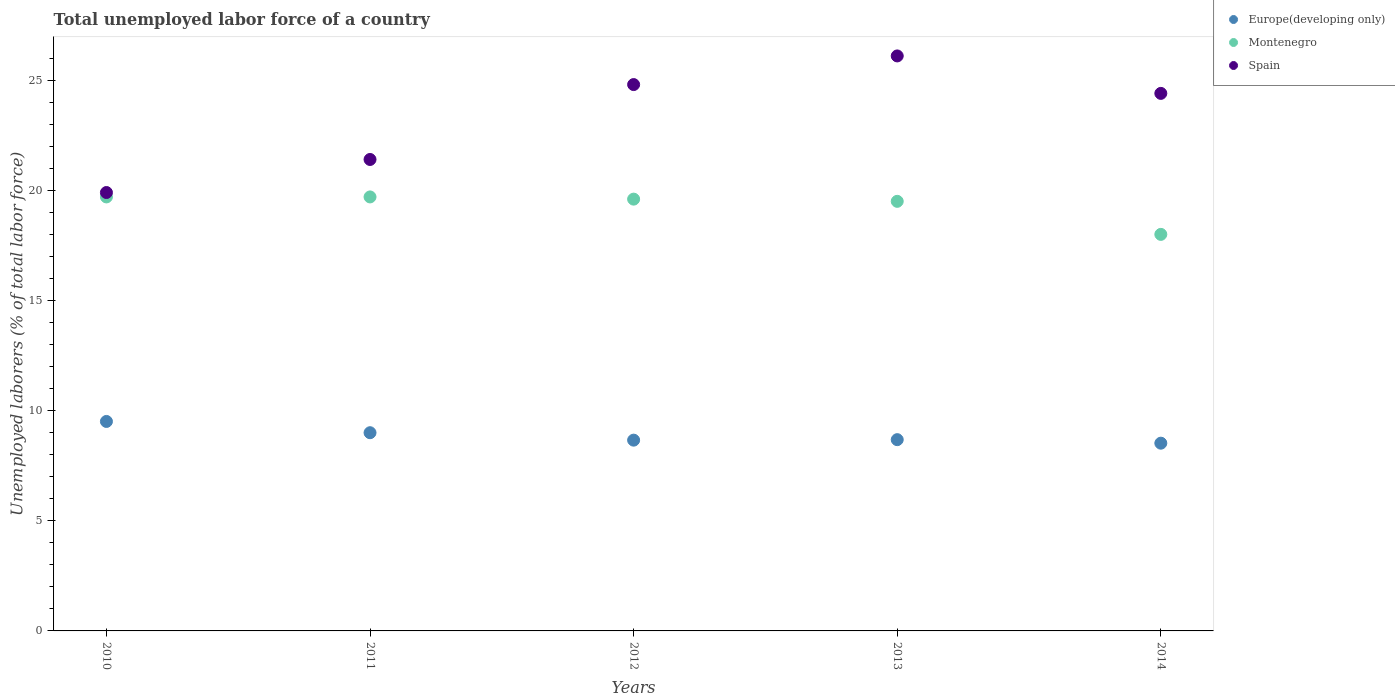What is the total unemployed labor force in Spain in 2010?
Provide a succinct answer. 19.9. Across all years, what is the maximum total unemployed labor force in Montenegro?
Your answer should be compact. 19.7. What is the total total unemployed labor force in Europe(developing only) in the graph?
Your answer should be compact. 44.37. What is the difference between the total unemployed labor force in Europe(developing only) in 2011 and that in 2013?
Offer a terse response. 0.32. What is the difference between the total unemployed labor force in Montenegro in 2013 and the total unemployed labor force in Spain in 2010?
Provide a succinct answer. -0.4. What is the average total unemployed labor force in Europe(developing only) per year?
Provide a short and direct response. 8.87. In the year 2013, what is the difference between the total unemployed labor force in Spain and total unemployed labor force in Montenegro?
Provide a short and direct response. 6.6. What is the ratio of the total unemployed labor force in Montenegro in 2011 to that in 2014?
Offer a terse response. 1.09. What is the difference between the highest and the second highest total unemployed labor force in Spain?
Your response must be concise. 1.3. What is the difference between the highest and the lowest total unemployed labor force in Montenegro?
Make the answer very short. 1.7. In how many years, is the total unemployed labor force in Europe(developing only) greater than the average total unemployed labor force in Europe(developing only) taken over all years?
Give a very brief answer. 2. Does the total unemployed labor force in Spain monotonically increase over the years?
Give a very brief answer. No. How many dotlines are there?
Your response must be concise. 3. How many years are there in the graph?
Provide a short and direct response. 5. Does the graph contain grids?
Your response must be concise. No. Where does the legend appear in the graph?
Provide a short and direct response. Top right. What is the title of the graph?
Ensure brevity in your answer.  Total unemployed labor force of a country. Does "Korea (Republic)" appear as one of the legend labels in the graph?
Provide a short and direct response. No. What is the label or title of the X-axis?
Your answer should be very brief. Years. What is the label or title of the Y-axis?
Give a very brief answer. Unemployed laborers (% of total labor force). What is the Unemployed laborers (% of total labor force) in Europe(developing only) in 2010?
Offer a very short reply. 9.51. What is the Unemployed laborers (% of total labor force) in Montenegro in 2010?
Your answer should be compact. 19.7. What is the Unemployed laborers (% of total labor force) in Spain in 2010?
Your answer should be very brief. 19.9. What is the Unemployed laborers (% of total labor force) in Europe(developing only) in 2011?
Provide a succinct answer. 9. What is the Unemployed laborers (% of total labor force) of Montenegro in 2011?
Your answer should be compact. 19.7. What is the Unemployed laborers (% of total labor force) in Spain in 2011?
Offer a very short reply. 21.4. What is the Unemployed laborers (% of total labor force) of Europe(developing only) in 2012?
Offer a terse response. 8.66. What is the Unemployed laborers (% of total labor force) in Montenegro in 2012?
Your answer should be very brief. 19.6. What is the Unemployed laborers (% of total labor force) in Spain in 2012?
Give a very brief answer. 24.8. What is the Unemployed laborers (% of total labor force) in Europe(developing only) in 2013?
Keep it short and to the point. 8.68. What is the Unemployed laborers (% of total labor force) of Montenegro in 2013?
Your answer should be very brief. 19.5. What is the Unemployed laborers (% of total labor force) in Spain in 2013?
Provide a succinct answer. 26.1. What is the Unemployed laborers (% of total labor force) in Europe(developing only) in 2014?
Give a very brief answer. 8.52. What is the Unemployed laborers (% of total labor force) of Spain in 2014?
Give a very brief answer. 24.4. Across all years, what is the maximum Unemployed laborers (% of total labor force) of Europe(developing only)?
Provide a short and direct response. 9.51. Across all years, what is the maximum Unemployed laborers (% of total labor force) in Montenegro?
Provide a short and direct response. 19.7. Across all years, what is the maximum Unemployed laborers (% of total labor force) of Spain?
Make the answer very short. 26.1. Across all years, what is the minimum Unemployed laborers (% of total labor force) in Europe(developing only)?
Your response must be concise. 8.52. Across all years, what is the minimum Unemployed laborers (% of total labor force) of Montenegro?
Keep it short and to the point. 18. Across all years, what is the minimum Unemployed laborers (% of total labor force) in Spain?
Your answer should be very brief. 19.9. What is the total Unemployed laborers (% of total labor force) of Europe(developing only) in the graph?
Give a very brief answer. 44.37. What is the total Unemployed laborers (% of total labor force) in Montenegro in the graph?
Ensure brevity in your answer.  96.5. What is the total Unemployed laborers (% of total labor force) of Spain in the graph?
Provide a succinct answer. 116.6. What is the difference between the Unemployed laborers (% of total labor force) in Europe(developing only) in 2010 and that in 2011?
Your response must be concise. 0.51. What is the difference between the Unemployed laborers (% of total labor force) in Europe(developing only) in 2010 and that in 2012?
Offer a very short reply. 0.85. What is the difference between the Unemployed laborers (% of total labor force) of Montenegro in 2010 and that in 2012?
Offer a very short reply. 0.1. What is the difference between the Unemployed laborers (% of total labor force) in Spain in 2010 and that in 2012?
Give a very brief answer. -4.9. What is the difference between the Unemployed laborers (% of total labor force) of Europe(developing only) in 2010 and that in 2013?
Provide a short and direct response. 0.83. What is the difference between the Unemployed laborers (% of total labor force) in Spain in 2010 and that in 2013?
Give a very brief answer. -6.2. What is the difference between the Unemployed laborers (% of total labor force) in Europe(developing only) in 2010 and that in 2014?
Provide a short and direct response. 0.99. What is the difference between the Unemployed laborers (% of total labor force) of Spain in 2010 and that in 2014?
Provide a short and direct response. -4.5. What is the difference between the Unemployed laborers (% of total labor force) in Europe(developing only) in 2011 and that in 2012?
Keep it short and to the point. 0.34. What is the difference between the Unemployed laborers (% of total labor force) of Spain in 2011 and that in 2012?
Your answer should be compact. -3.4. What is the difference between the Unemployed laborers (% of total labor force) in Europe(developing only) in 2011 and that in 2013?
Your answer should be very brief. 0.32. What is the difference between the Unemployed laborers (% of total labor force) of Europe(developing only) in 2011 and that in 2014?
Keep it short and to the point. 0.48. What is the difference between the Unemployed laborers (% of total labor force) of Montenegro in 2011 and that in 2014?
Ensure brevity in your answer.  1.7. What is the difference between the Unemployed laborers (% of total labor force) in Spain in 2011 and that in 2014?
Offer a terse response. -3. What is the difference between the Unemployed laborers (% of total labor force) of Europe(developing only) in 2012 and that in 2013?
Your response must be concise. -0.02. What is the difference between the Unemployed laborers (% of total labor force) of Europe(developing only) in 2012 and that in 2014?
Offer a very short reply. 0.14. What is the difference between the Unemployed laborers (% of total labor force) of Montenegro in 2012 and that in 2014?
Provide a succinct answer. 1.6. What is the difference between the Unemployed laborers (% of total labor force) in Europe(developing only) in 2013 and that in 2014?
Keep it short and to the point. 0.16. What is the difference between the Unemployed laborers (% of total labor force) in Montenegro in 2013 and that in 2014?
Offer a very short reply. 1.5. What is the difference between the Unemployed laborers (% of total labor force) of Europe(developing only) in 2010 and the Unemployed laborers (% of total labor force) of Montenegro in 2011?
Provide a short and direct response. -10.19. What is the difference between the Unemployed laborers (% of total labor force) in Europe(developing only) in 2010 and the Unemployed laborers (% of total labor force) in Spain in 2011?
Your response must be concise. -11.89. What is the difference between the Unemployed laborers (% of total labor force) in Montenegro in 2010 and the Unemployed laborers (% of total labor force) in Spain in 2011?
Your response must be concise. -1.7. What is the difference between the Unemployed laborers (% of total labor force) of Europe(developing only) in 2010 and the Unemployed laborers (% of total labor force) of Montenegro in 2012?
Give a very brief answer. -10.09. What is the difference between the Unemployed laborers (% of total labor force) in Europe(developing only) in 2010 and the Unemployed laborers (% of total labor force) in Spain in 2012?
Ensure brevity in your answer.  -15.29. What is the difference between the Unemployed laborers (% of total labor force) in Europe(developing only) in 2010 and the Unemployed laborers (% of total labor force) in Montenegro in 2013?
Offer a terse response. -9.99. What is the difference between the Unemployed laborers (% of total labor force) of Europe(developing only) in 2010 and the Unemployed laborers (% of total labor force) of Spain in 2013?
Make the answer very short. -16.59. What is the difference between the Unemployed laborers (% of total labor force) in Europe(developing only) in 2010 and the Unemployed laborers (% of total labor force) in Montenegro in 2014?
Offer a terse response. -8.49. What is the difference between the Unemployed laborers (% of total labor force) in Europe(developing only) in 2010 and the Unemployed laborers (% of total labor force) in Spain in 2014?
Keep it short and to the point. -14.89. What is the difference between the Unemployed laborers (% of total labor force) of Montenegro in 2010 and the Unemployed laborers (% of total labor force) of Spain in 2014?
Provide a succinct answer. -4.7. What is the difference between the Unemployed laborers (% of total labor force) of Europe(developing only) in 2011 and the Unemployed laborers (% of total labor force) of Montenegro in 2012?
Keep it short and to the point. -10.6. What is the difference between the Unemployed laborers (% of total labor force) in Europe(developing only) in 2011 and the Unemployed laborers (% of total labor force) in Spain in 2012?
Your response must be concise. -15.8. What is the difference between the Unemployed laborers (% of total labor force) of Montenegro in 2011 and the Unemployed laborers (% of total labor force) of Spain in 2012?
Give a very brief answer. -5.1. What is the difference between the Unemployed laborers (% of total labor force) of Europe(developing only) in 2011 and the Unemployed laborers (% of total labor force) of Montenegro in 2013?
Make the answer very short. -10.5. What is the difference between the Unemployed laborers (% of total labor force) in Europe(developing only) in 2011 and the Unemployed laborers (% of total labor force) in Spain in 2013?
Offer a very short reply. -17.1. What is the difference between the Unemployed laborers (% of total labor force) in Europe(developing only) in 2011 and the Unemployed laborers (% of total labor force) in Montenegro in 2014?
Offer a terse response. -9. What is the difference between the Unemployed laborers (% of total labor force) in Europe(developing only) in 2011 and the Unemployed laborers (% of total labor force) in Spain in 2014?
Keep it short and to the point. -15.4. What is the difference between the Unemployed laborers (% of total labor force) of Europe(developing only) in 2012 and the Unemployed laborers (% of total labor force) of Montenegro in 2013?
Offer a very short reply. -10.84. What is the difference between the Unemployed laborers (% of total labor force) in Europe(developing only) in 2012 and the Unemployed laborers (% of total labor force) in Spain in 2013?
Provide a short and direct response. -17.44. What is the difference between the Unemployed laborers (% of total labor force) of Montenegro in 2012 and the Unemployed laborers (% of total labor force) of Spain in 2013?
Provide a short and direct response. -6.5. What is the difference between the Unemployed laborers (% of total labor force) in Europe(developing only) in 2012 and the Unemployed laborers (% of total labor force) in Montenegro in 2014?
Make the answer very short. -9.34. What is the difference between the Unemployed laborers (% of total labor force) in Europe(developing only) in 2012 and the Unemployed laborers (% of total labor force) in Spain in 2014?
Offer a very short reply. -15.74. What is the difference between the Unemployed laborers (% of total labor force) of Europe(developing only) in 2013 and the Unemployed laborers (% of total labor force) of Montenegro in 2014?
Offer a terse response. -9.32. What is the difference between the Unemployed laborers (% of total labor force) of Europe(developing only) in 2013 and the Unemployed laborers (% of total labor force) of Spain in 2014?
Keep it short and to the point. -15.72. What is the average Unemployed laborers (% of total labor force) of Europe(developing only) per year?
Ensure brevity in your answer.  8.87. What is the average Unemployed laborers (% of total labor force) of Montenegro per year?
Offer a terse response. 19.3. What is the average Unemployed laborers (% of total labor force) of Spain per year?
Keep it short and to the point. 23.32. In the year 2010, what is the difference between the Unemployed laborers (% of total labor force) of Europe(developing only) and Unemployed laborers (% of total labor force) of Montenegro?
Ensure brevity in your answer.  -10.19. In the year 2010, what is the difference between the Unemployed laborers (% of total labor force) in Europe(developing only) and Unemployed laborers (% of total labor force) in Spain?
Your answer should be compact. -10.39. In the year 2011, what is the difference between the Unemployed laborers (% of total labor force) in Europe(developing only) and Unemployed laborers (% of total labor force) in Montenegro?
Ensure brevity in your answer.  -10.7. In the year 2011, what is the difference between the Unemployed laborers (% of total labor force) of Europe(developing only) and Unemployed laborers (% of total labor force) of Spain?
Offer a very short reply. -12.4. In the year 2011, what is the difference between the Unemployed laborers (% of total labor force) of Montenegro and Unemployed laborers (% of total labor force) of Spain?
Your response must be concise. -1.7. In the year 2012, what is the difference between the Unemployed laborers (% of total labor force) of Europe(developing only) and Unemployed laborers (% of total labor force) of Montenegro?
Provide a succinct answer. -10.94. In the year 2012, what is the difference between the Unemployed laborers (% of total labor force) of Europe(developing only) and Unemployed laborers (% of total labor force) of Spain?
Provide a succinct answer. -16.14. In the year 2012, what is the difference between the Unemployed laborers (% of total labor force) in Montenegro and Unemployed laborers (% of total labor force) in Spain?
Provide a short and direct response. -5.2. In the year 2013, what is the difference between the Unemployed laborers (% of total labor force) in Europe(developing only) and Unemployed laborers (% of total labor force) in Montenegro?
Provide a succinct answer. -10.82. In the year 2013, what is the difference between the Unemployed laborers (% of total labor force) in Europe(developing only) and Unemployed laborers (% of total labor force) in Spain?
Keep it short and to the point. -17.42. In the year 2013, what is the difference between the Unemployed laborers (% of total labor force) in Montenegro and Unemployed laborers (% of total labor force) in Spain?
Give a very brief answer. -6.6. In the year 2014, what is the difference between the Unemployed laborers (% of total labor force) of Europe(developing only) and Unemployed laborers (% of total labor force) of Montenegro?
Your answer should be compact. -9.48. In the year 2014, what is the difference between the Unemployed laborers (% of total labor force) of Europe(developing only) and Unemployed laborers (% of total labor force) of Spain?
Ensure brevity in your answer.  -15.88. What is the ratio of the Unemployed laborers (% of total labor force) of Europe(developing only) in 2010 to that in 2011?
Provide a succinct answer. 1.06. What is the ratio of the Unemployed laborers (% of total labor force) of Spain in 2010 to that in 2011?
Ensure brevity in your answer.  0.93. What is the ratio of the Unemployed laborers (% of total labor force) in Europe(developing only) in 2010 to that in 2012?
Your response must be concise. 1.1. What is the ratio of the Unemployed laborers (% of total labor force) of Spain in 2010 to that in 2012?
Offer a terse response. 0.8. What is the ratio of the Unemployed laborers (% of total labor force) in Europe(developing only) in 2010 to that in 2013?
Make the answer very short. 1.1. What is the ratio of the Unemployed laborers (% of total labor force) of Montenegro in 2010 to that in 2013?
Your answer should be compact. 1.01. What is the ratio of the Unemployed laborers (% of total labor force) of Spain in 2010 to that in 2013?
Make the answer very short. 0.76. What is the ratio of the Unemployed laborers (% of total labor force) in Europe(developing only) in 2010 to that in 2014?
Offer a very short reply. 1.12. What is the ratio of the Unemployed laborers (% of total labor force) in Montenegro in 2010 to that in 2014?
Provide a short and direct response. 1.09. What is the ratio of the Unemployed laborers (% of total labor force) in Spain in 2010 to that in 2014?
Give a very brief answer. 0.82. What is the ratio of the Unemployed laborers (% of total labor force) in Europe(developing only) in 2011 to that in 2012?
Provide a succinct answer. 1.04. What is the ratio of the Unemployed laborers (% of total labor force) of Spain in 2011 to that in 2012?
Provide a succinct answer. 0.86. What is the ratio of the Unemployed laborers (% of total labor force) of Europe(developing only) in 2011 to that in 2013?
Make the answer very short. 1.04. What is the ratio of the Unemployed laborers (% of total labor force) of Montenegro in 2011 to that in 2013?
Offer a very short reply. 1.01. What is the ratio of the Unemployed laborers (% of total labor force) in Spain in 2011 to that in 2013?
Give a very brief answer. 0.82. What is the ratio of the Unemployed laborers (% of total labor force) of Europe(developing only) in 2011 to that in 2014?
Provide a short and direct response. 1.06. What is the ratio of the Unemployed laborers (% of total labor force) of Montenegro in 2011 to that in 2014?
Your answer should be very brief. 1.09. What is the ratio of the Unemployed laborers (% of total labor force) in Spain in 2011 to that in 2014?
Keep it short and to the point. 0.88. What is the ratio of the Unemployed laborers (% of total labor force) of Europe(developing only) in 2012 to that in 2013?
Make the answer very short. 1. What is the ratio of the Unemployed laborers (% of total labor force) in Montenegro in 2012 to that in 2013?
Ensure brevity in your answer.  1.01. What is the ratio of the Unemployed laborers (% of total labor force) of Spain in 2012 to that in 2013?
Provide a short and direct response. 0.95. What is the ratio of the Unemployed laborers (% of total labor force) of Europe(developing only) in 2012 to that in 2014?
Your answer should be very brief. 1.02. What is the ratio of the Unemployed laborers (% of total labor force) of Montenegro in 2012 to that in 2014?
Offer a terse response. 1.09. What is the ratio of the Unemployed laborers (% of total labor force) in Spain in 2012 to that in 2014?
Make the answer very short. 1.02. What is the ratio of the Unemployed laborers (% of total labor force) of Europe(developing only) in 2013 to that in 2014?
Make the answer very short. 1.02. What is the ratio of the Unemployed laborers (% of total labor force) of Spain in 2013 to that in 2014?
Provide a succinct answer. 1.07. What is the difference between the highest and the second highest Unemployed laborers (% of total labor force) in Europe(developing only)?
Give a very brief answer. 0.51. What is the difference between the highest and the second highest Unemployed laborers (% of total labor force) of Montenegro?
Keep it short and to the point. 0. What is the difference between the highest and the second highest Unemployed laborers (% of total labor force) in Spain?
Provide a short and direct response. 1.3. What is the difference between the highest and the lowest Unemployed laborers (% of total labor force) in Europe(developing only)?
Provide a short and direct response. 0.99. What is the difference between the highest and the lowest Unemployed laborers (% of total labor force) in Spain?
Your response must be concise. 6.2. 